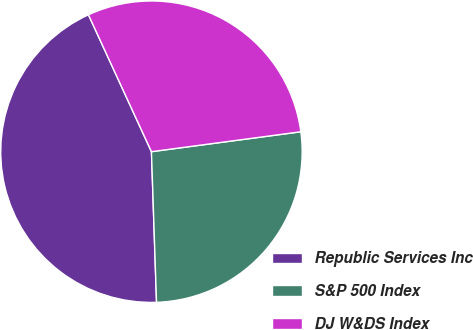Convert chart. <chart><loc_0><loc_0><loc_500><loc_500><pie_chart><fcel>Republic Services Inc<fcel>S&P 500 Index<fcel>DJ W&DS Index<nl><fcel>43.67%<fcel>26.57%<fcel>29.75%<nl></chart> 